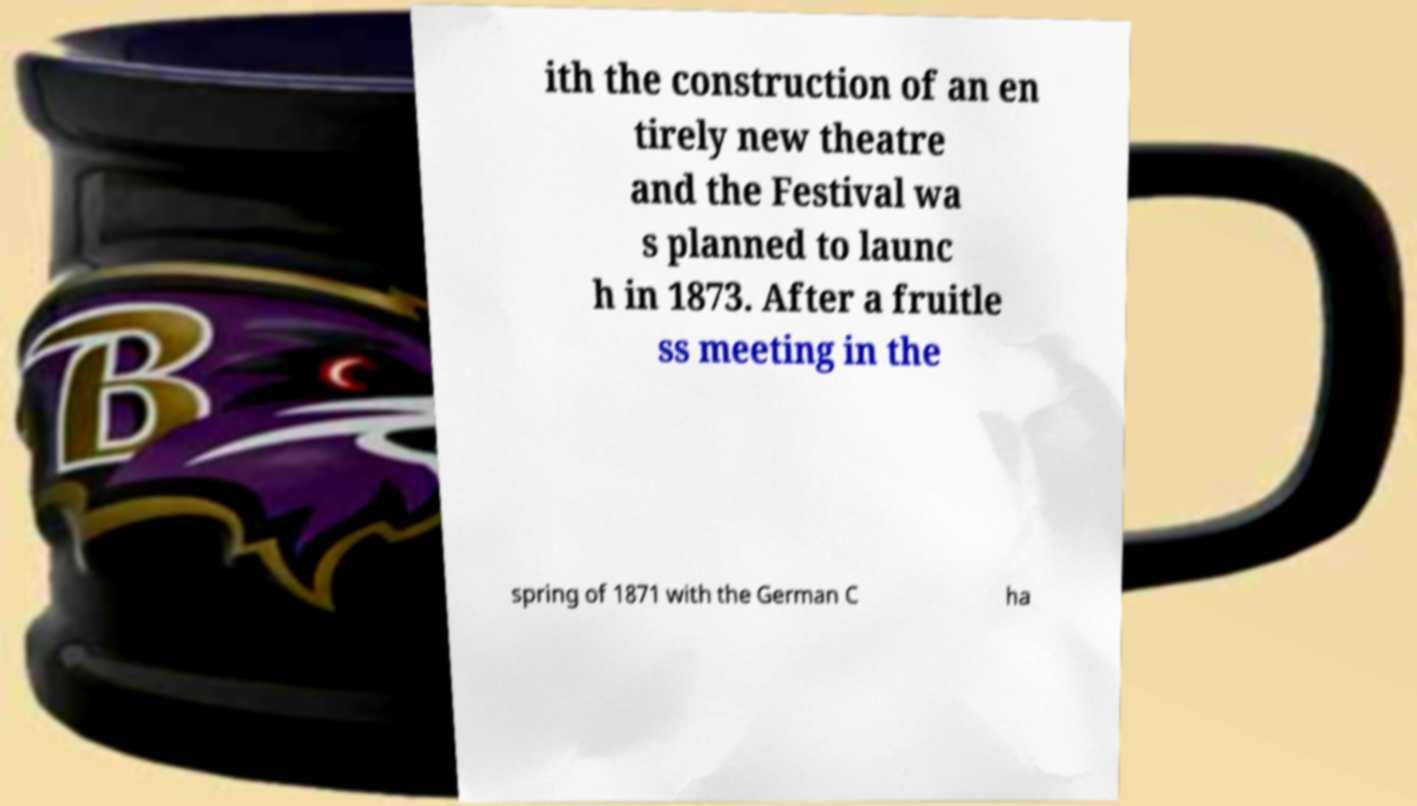There's text embedded in this image that I need extracted. Can you transcribe it verbatim? ith the construction of an en tirely new theatre and the Festival wa s planned to launc h in 1873. After a fruitle ss meeting in the spring of 1871 with the German C ha 